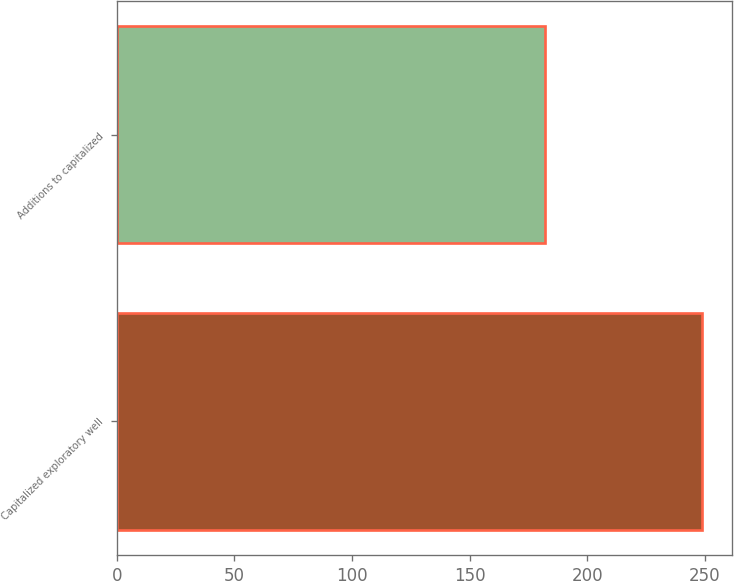Convert chart. <chart><loc_0><loc_0><loc_500><loc_500><bar_chart><fcel>Capitalized exploratory well<fcel>Additions to capitalized<nl><fcel>249<fcel>182<nl></chart> 